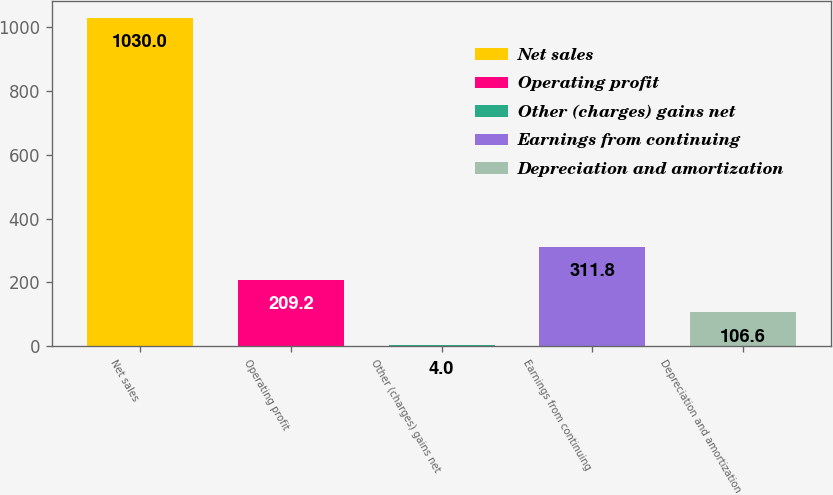<chart> <loc_0><loc_0><loc_500><loc_500><bar_chart><fcel>Net sales<fcel>Operating profit<fcel>Other (charges) gains net<fcel>Earnings from continuing<fcel>Depreciation and amortization<nl><fcel>1030<fcel>209.2<fcel>4<fcel>311.8<fcel>106.6<nl></chart> 